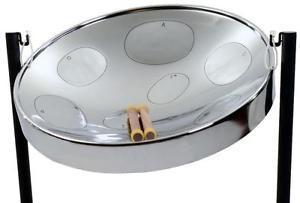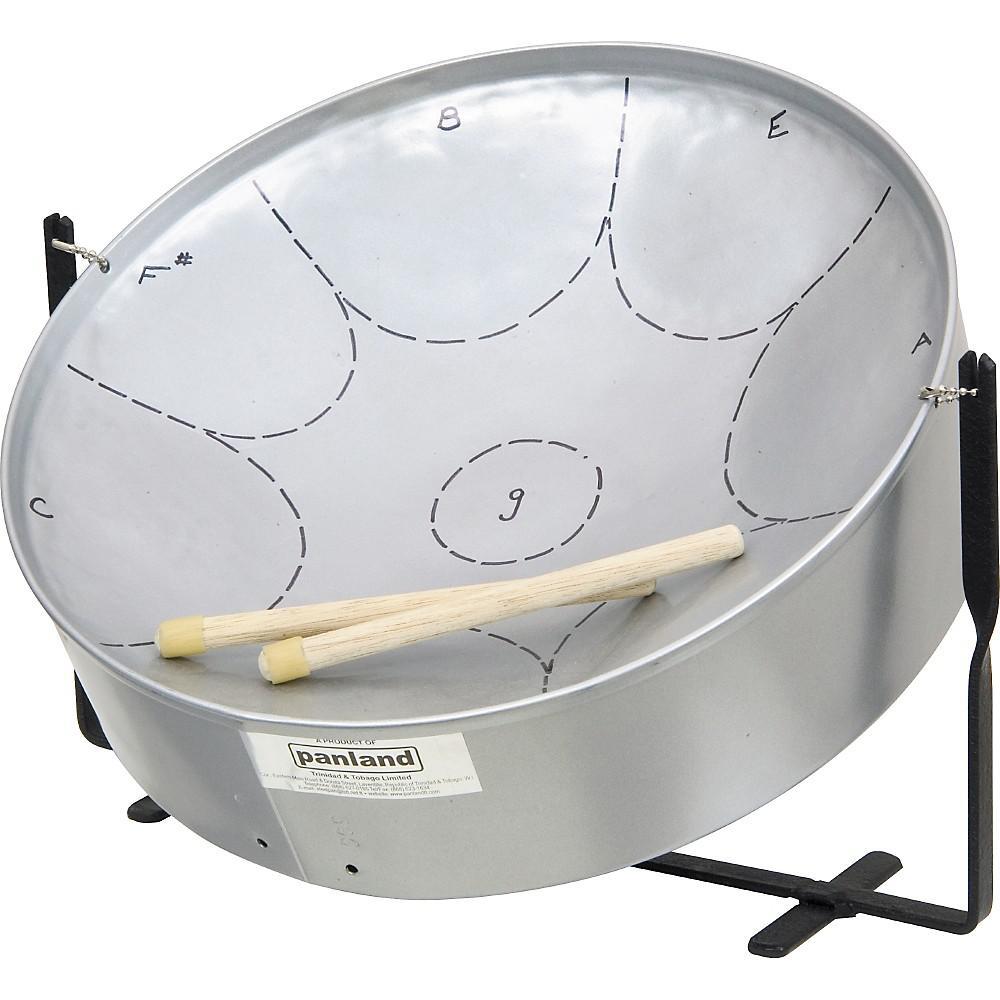The first image is the image on the left, the second image is the image on the right. Assess this claim about the two images: "The designs of two steel drums are different, as are their stands, but each has two sticks resting in the drum.". Correct or not? Answer yes or no. Yes. The first image is the image on the left, the second image is the image on the right. Analyze the images presented: Is the assertion "The right image contains a single chrome metal drum with two drum sticks resting on top of the drum." valid? Answer yes or no. Yes. 